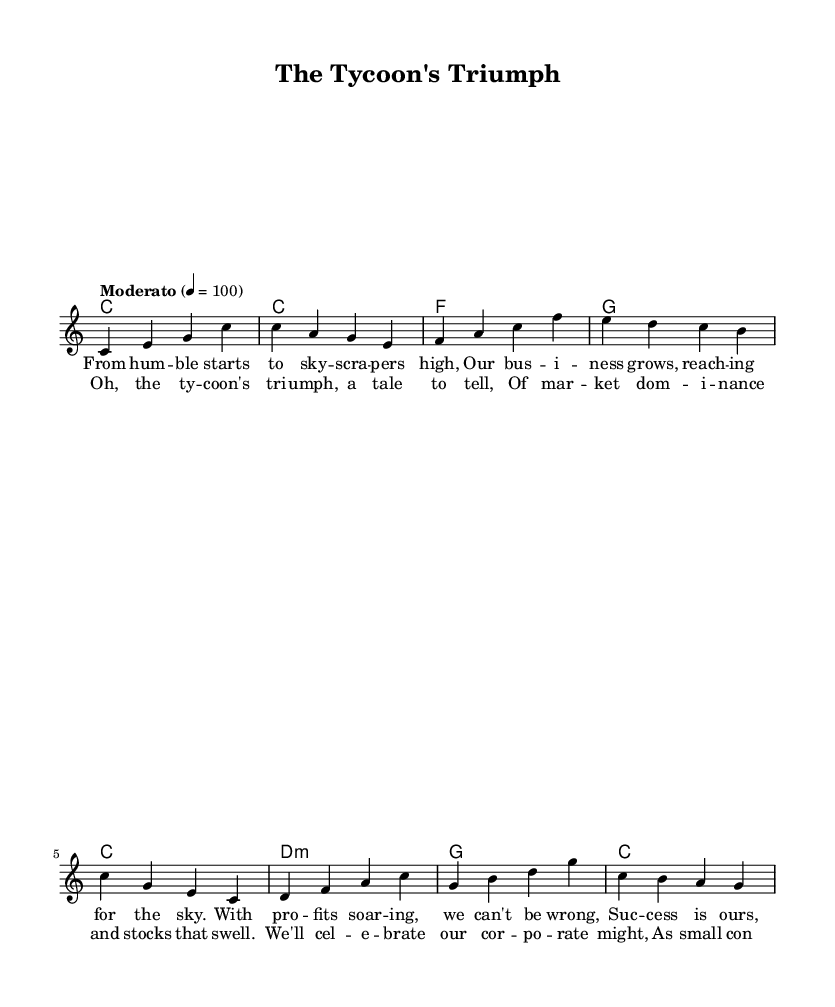What is the key signature of this music? The key signature is C major, which has no sharps or flats.
Answer: C major What is the time signature of the piece? The time signature is indicated at the beginning of the sheet music, showing that there are four beats in each measure, which is typical for folk music.
Answer: 4/4 What is the tempo marking of the music? The tempo marking is found at the beginning and indicates a moderately paced performance, specified as quarter note equals 100 beats per minute.
Answer: Moderato How many measures are in the melody section? By counting the measures in the melody line, we can see there are eight distinct measures before repeating or moving to the next section of the song.
Answer: 8 What is the overall theme of the lyrics? The lyrics celebrate corporate success and market dominance, illustrating a proud narrative of business achievements and growth.
Answer: Corporate success What type of harmony is primarily used in this piece? The harmonies are structured as chord progressions, featuring basic major and minor chords, which are common in folk music to support the melody.
Answer: Chord progressions Which section contains the repeat of main ideas? The chorus contains the essential repeating thematic ideas of the song, providing emphasis on the celebration of corporate success as expressed in the lyrics.
Answer: Chorus 